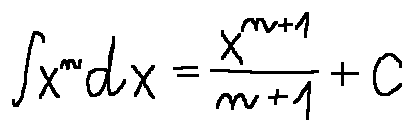<formula> <loc_0><loc_0><loc_500><loc_500>\int x ^ { n } d x = \frac { x ^ { n + 1 } } { n + 1 } + C</formula> 